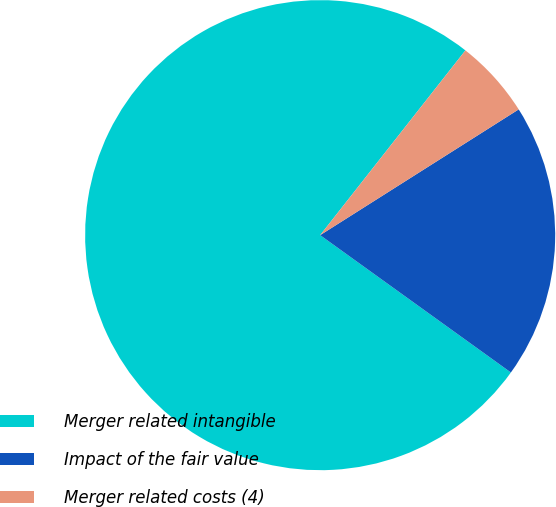<chart> <loc_0><loc_0><loc_500><loc_500><pie_chart><fcel>Merger related intangible<fcel>Impact of the fair value<fcel>Merger related costs (4)<nl><fcel>75.68%<fcel>18.92%<fcel>5.41%<nl></chart> 